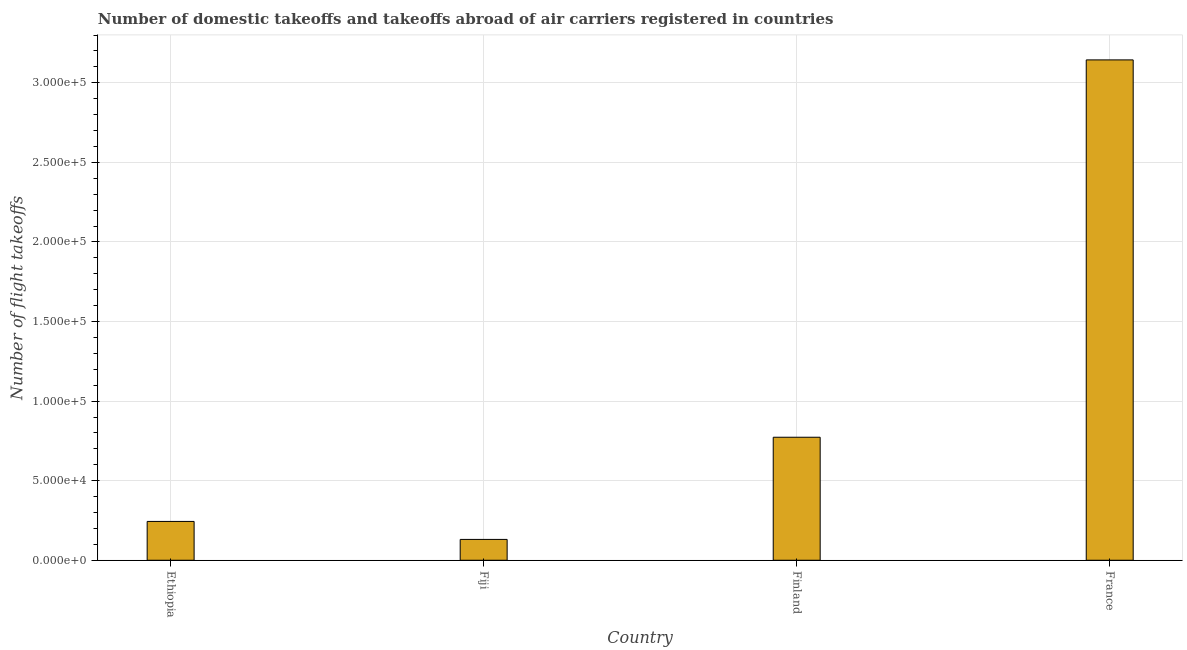What is the title of the graph?
Make the answer very short. Number of domestic takeoffs and takeoffs abroad of air carriers registered in countries. What is the label or title of the Y-axis?
Offer a very short reply. Number of flight takeoffs. What is the number of flight takeoffs in France?
Your response must be concise. 3.14e+05. Across all countries, what is the maximum number of flight takeoffs?
Your response must be concise. 3.14e+05. Across all countries, what is the minimum number of flight takeoffs?
Your response must be concise. 1.31e+04. In which country was the number of flight takeoffs maximum?
Offer a very short reply. France. In which country was the number of flight takeoffs minimum?
Provide a succinct answer. Fiji. What is the sum of the number of flight takeoffs?
Provide a short and direct response. 4.29e+05. What is the difference between the number of flight takeoffs in Finland and France?
Give a very brief answer. -2.37e+05. What is the average number of flight takeoffs per country?
Keep it short and to the point. 1.07e+05. What is the median number of flight takeoffs?
Keep it short and to the point. 5.08e+04. What is the ratio of the number of flight takeoffs in Finland to that in France?
Your answer should be very brief. 0.25. What is the difference between the highest and the second highest number of flight takeoffs?
Make the answer very short. 2.37e+05. Is the sum of the number of flight takeoffs in Ethiopia and Fiji greater than the maximum number of flight takeoffs across all countries?
Offer a terse response. No. What is the difference between the highest and the lowest number of flight takeoffs?
Offer a terse response. 3.01e+05. In how many countries, is the number of flight takeoffs greater than the average number of flight takeoffs taken over all countries?
Provide a short and direct response. 1. Are all the bars in the graph horizontal?
Provide a succinct answer. No. Are the values on the major ticks of Y-axis written in scientific E-notation?
Your response must be concise. Yes. What is the Number of flight takeoffs in Ethiopia?
Ensure brevity in your answer.  2.44e+04. What is the Number of flight takeoffs in Fiji?
Your response must be concise. 1.31e+04. What is the Number of flight takeoffs of Finland?
Keep it short and to the point. 7.73e+04. What is the Number of flight takeoffs in France?
Provide a succinct answer. 3.14e+05. What is the difference between the Number of flight takeoffs in Ethiopia and Fiji?
Provide a short and direct response. 1.13e+04. What is the difference between the Number of flight takeoffs in Ethiopia and Finland?
Make the answer very short. -5.29e+04. What is the difference between the Number of flight takeoffs in Ethiopia and France?
Your answer should be very brief. -2.90e+05. What is the difference between the Number of flight takeoffs in Fiji and Finland?
Offer a terse response. -6.42e+04. What is the difference between the Number of flight takeoffs in Fiji and France?
Give a very brief answer. -3.01e+05. What is the difference between the Number of flight takeoffs in Finland and France?
Make the answer very short. -2.37e+05. What is the ratio of the Number of flight takeoffs in Ethiopia to that in Fiji?
Provide a short and direct response. 1.86. What is the ratio of the Number of flight takeoffs in Ethiopia to that in Finland?
Provide a succinct answer. 0.32. What is the ratio of the Number of flight takeoffs in Ethiopia to that in France?
Keep it short and to the point. 0.08. What is the ratio of the Number of flight takeoffs in Fiji to that in Finland?
Give a very brief answer. 0.17. What is the ratio of the Number of flight takeoffs in Fiji to that in France?
Your answer should be very brief. 0.04. What is the ratio of the Number of flight takeoffs in Finland to that in France?
Offer a very short reply. 0.25. 